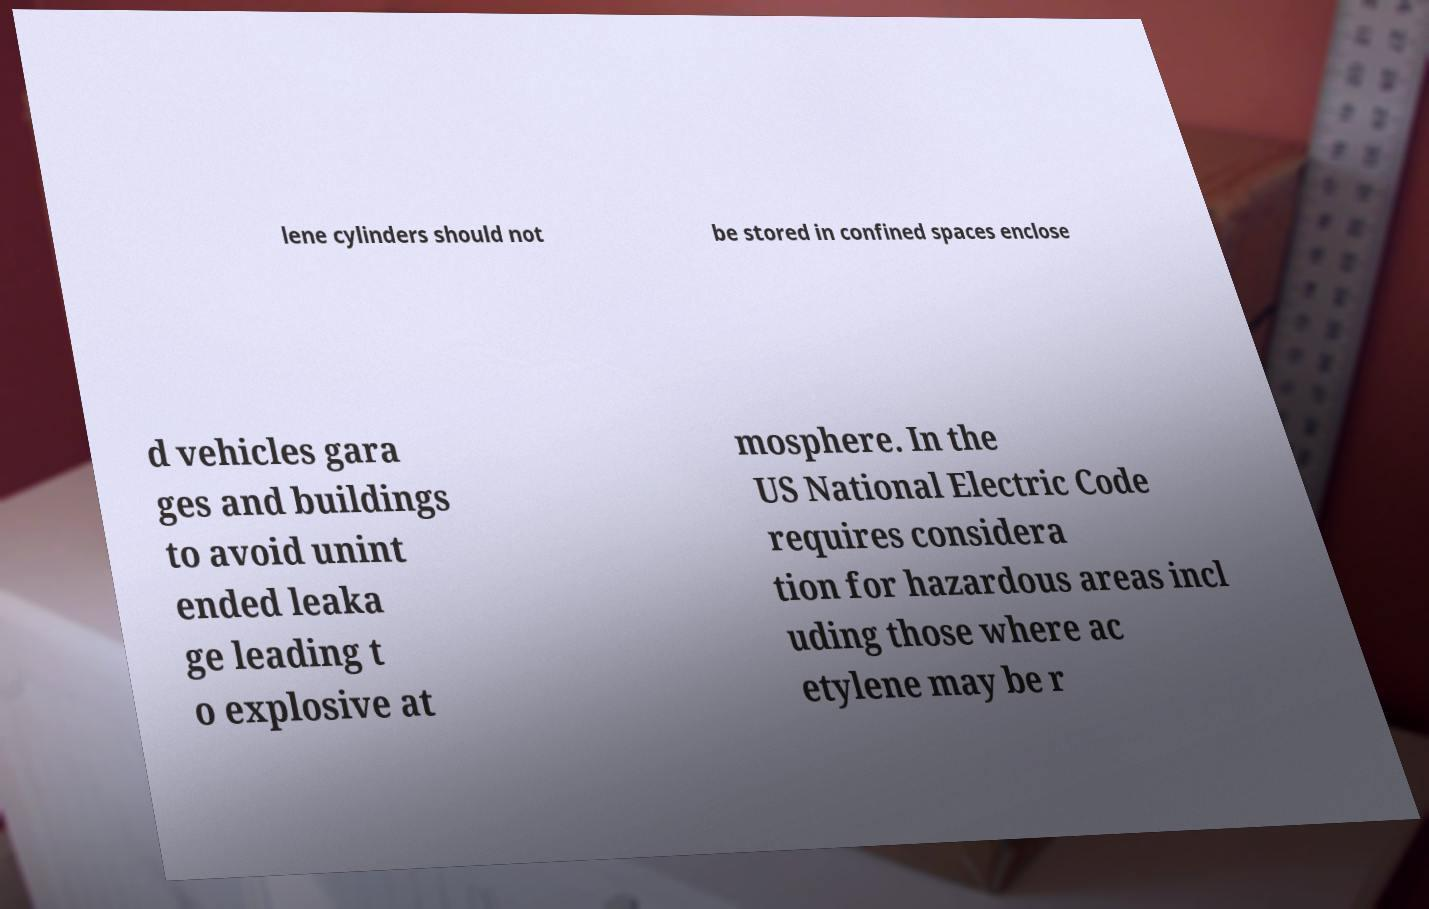Could you assist in decoding the text presented in this image and type it out clearly? lene cylinders should not be stored in confined spaces enclose d vehicles gara ges and buildings to avoid unint ended leaka ge leading t o explosive at mosphere. In the US National Electric Code requires considera tion for hazardous areas incl uding those where ac etylene may be r 